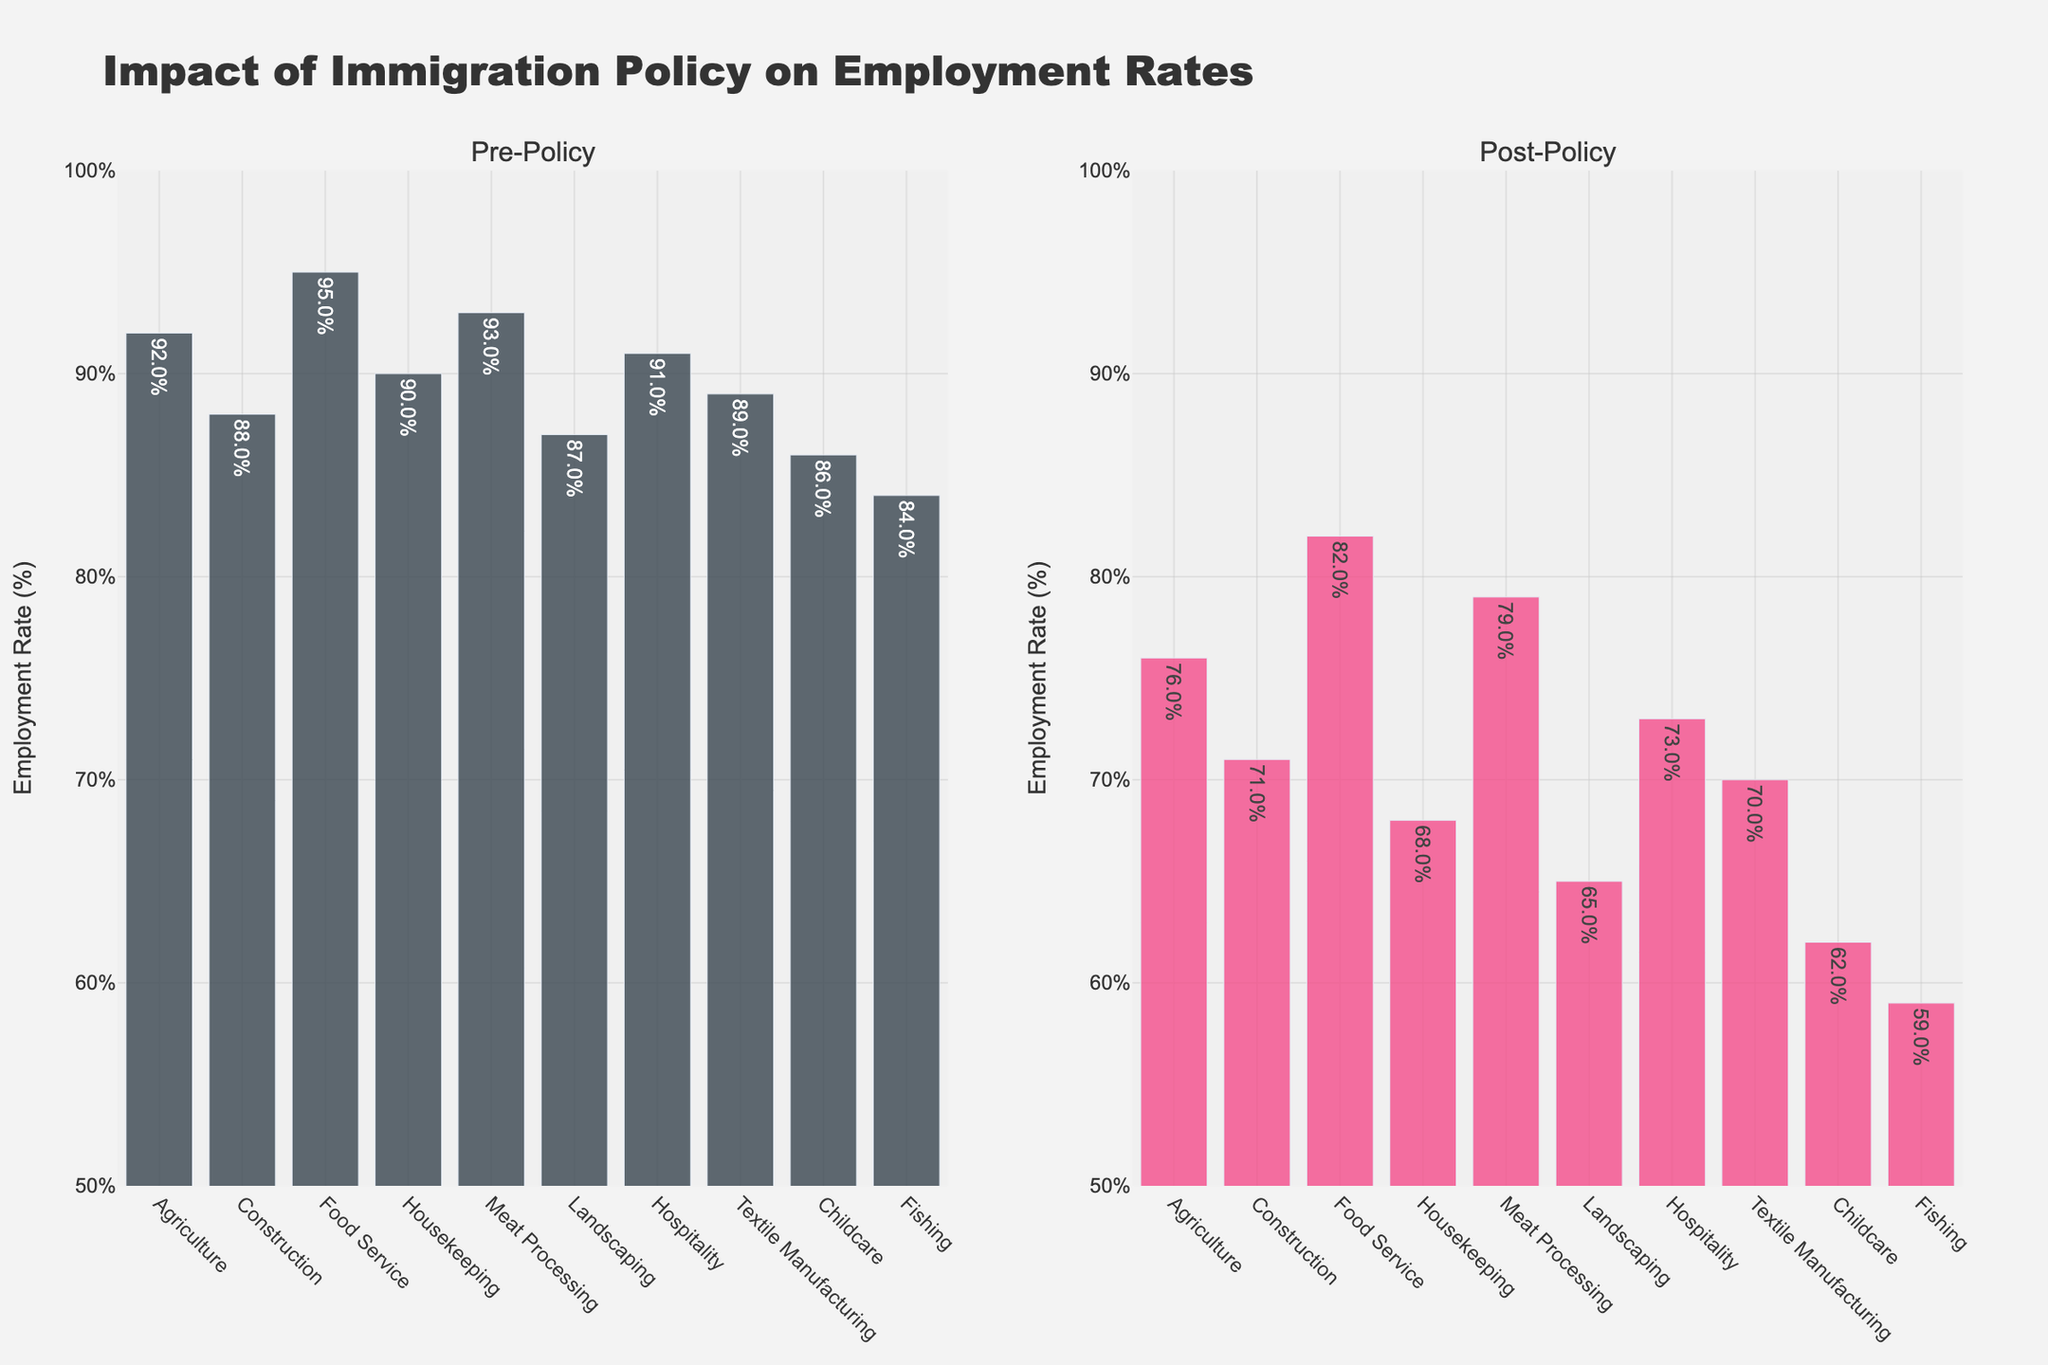Which industry experienced the largest decrease in employment rate after the policy change? Subtract the post-policy employment rates from the pre-policy rates for each industry. The largest decrease is found by comparing these differences. Childcare went from 86% to 62%, which is a decrease of 24%.
Answer: Childcare What is the difference between the pre-policy and post-policy employment rates in the Meat Processing industry? Subtract the post-policy employment rate (79%) from the pre-policy employment rate (93%) for the Meat Processing industry. The difference is 93% - 79% = 14%.
Answer: 14% Which industry had the smallest decrease in employment rate? Calculate the decrease for each industry by subtracting the post-policy rate from the pre-policy rate. The smallest decrease is 13% for Food Service, from 95% to 82%.
Answer: Food Service How many industries had a decrease of more than 20% in their employment rates? Calculate the decrease for each industry and count how many had decreases greater than 20%. Six industries had decreases over 20%: Agriculture, Construction, Housekeeping, Landscaping, Childcare, and Fishing.
Answer: 6 Which industry had the highest post-policy employment rate and what was it? Look at the post-policy employment rates for all industries and identify the highest one. Food Service had the highest post-policy employment rate of 82%.
Answer: Food Service, 82% Compare the employment rates change in Landscaping and Hospitality industries. Which one had a greater decrease in percentage points? Subtract the post-policy employment rate from the pre-policy rate for both industries. Landscaping decreased from 87% to 65% (22%), and Hospitality from 91% to 73% (18%). Therefore, Landscaping had a greater decrease.
Answer: Landscaping What is the average decrease in employment rates across all industries? Find the decreases for all industries, sum them, and then divide by the number of industries. The sum of decreases is 155% (24% + 17% + 13% + 22% + 14% + 22% + 18% + 19% + 24% + 25%). The average decrease is 155% / 10 = 15.5%.
Answer: 15.5% What was the post-policy employment rate in Construction compared to the pre-policy rate in Textile Manufacturing? The post-policy employment rate in Construction was 71%, and the pre-policy rate in Textile Manufacturing was 89%.
Answer: Construction 71%, Textile Manufacturing 89% 